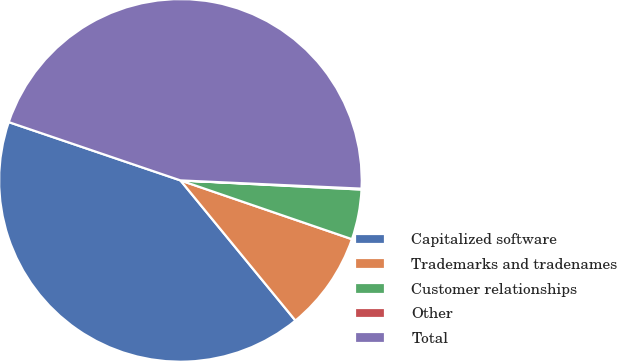<chart> <loc_0><loc_0><loc_500><loc_500><pie_chart><fcel>Capitalized software<fcel>Trademarks and tradenames<fcel>Customer relationships<fcel>Other<fcel>Total<nl><fcel>41.14%<fcel>8.81%<fcel>4.45%<fcel>0.08%<fcel>45.51%<nl></chart> 